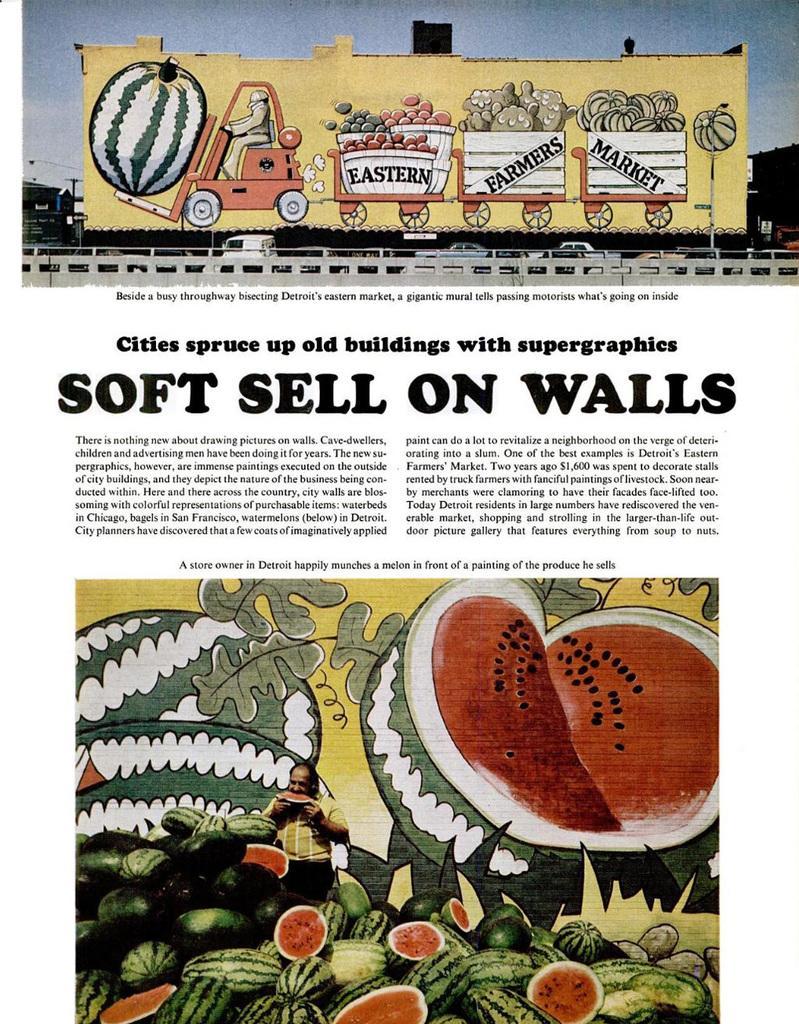In one or two sentences, can you explain what this image depicts? In this image, we can see a picture, there is a watermelon on the picture, there is SOFT SHELLS ON WALLS is printed on the wall. 